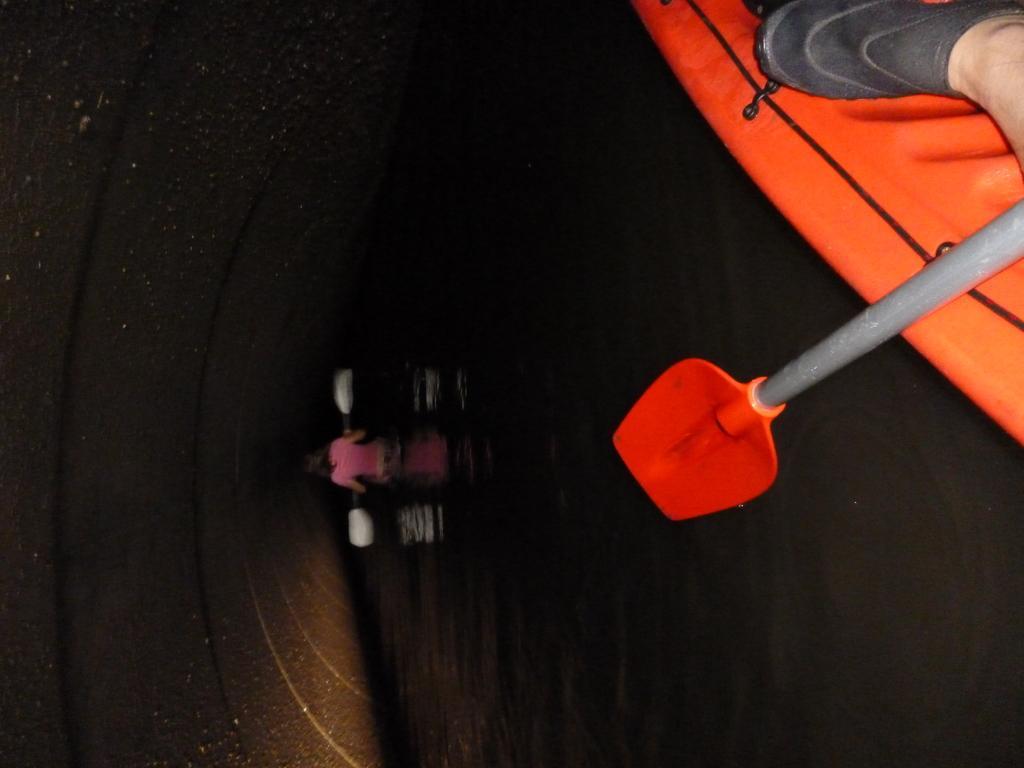Could you give a brief overview of what you see in this image? The image is captured from a boat and the boat is on a water surface. In a distance there is a person sailing a boat. 